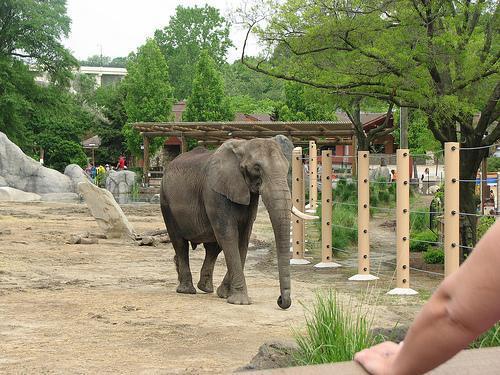How many feet does it have?
Give a very brief answer. 4. 